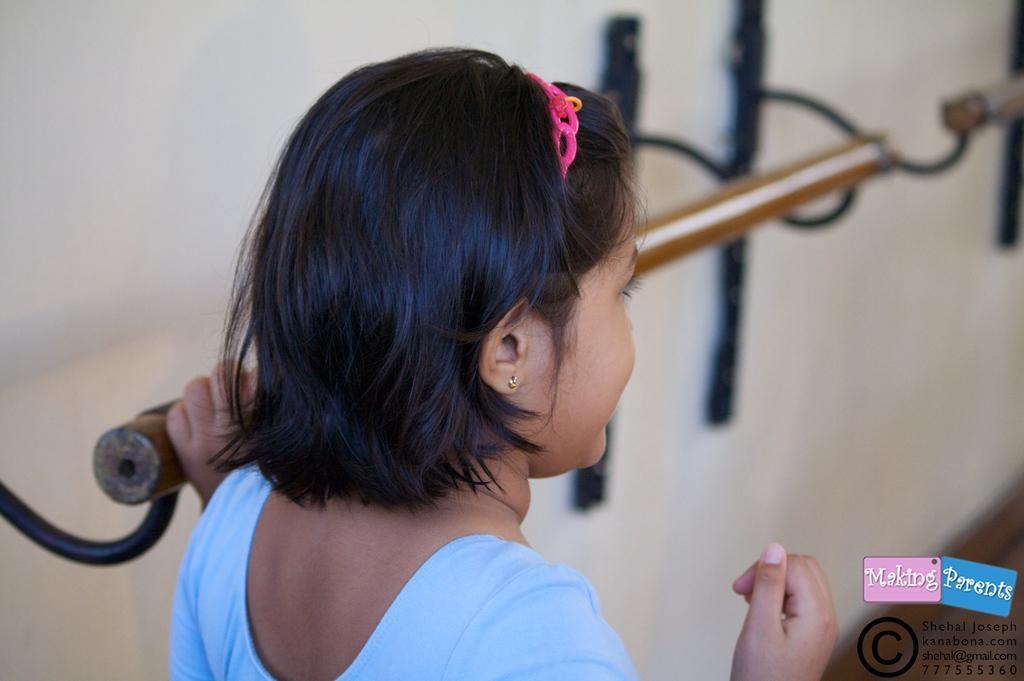Can you describe this image briefly? In this image we can see a girl. She is wearing a blue color dress. In the background, we can see a wall and stand. There is a watermark in the right bottom of the image. 